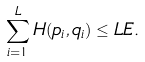Convert formula to latex. <formula><loc_0><loc_0><loc_500><loc_500>\sum _ { i = 1 } ^ { L } H ( p _ { i } , q _ { i } ) \leq L E .</formula> 